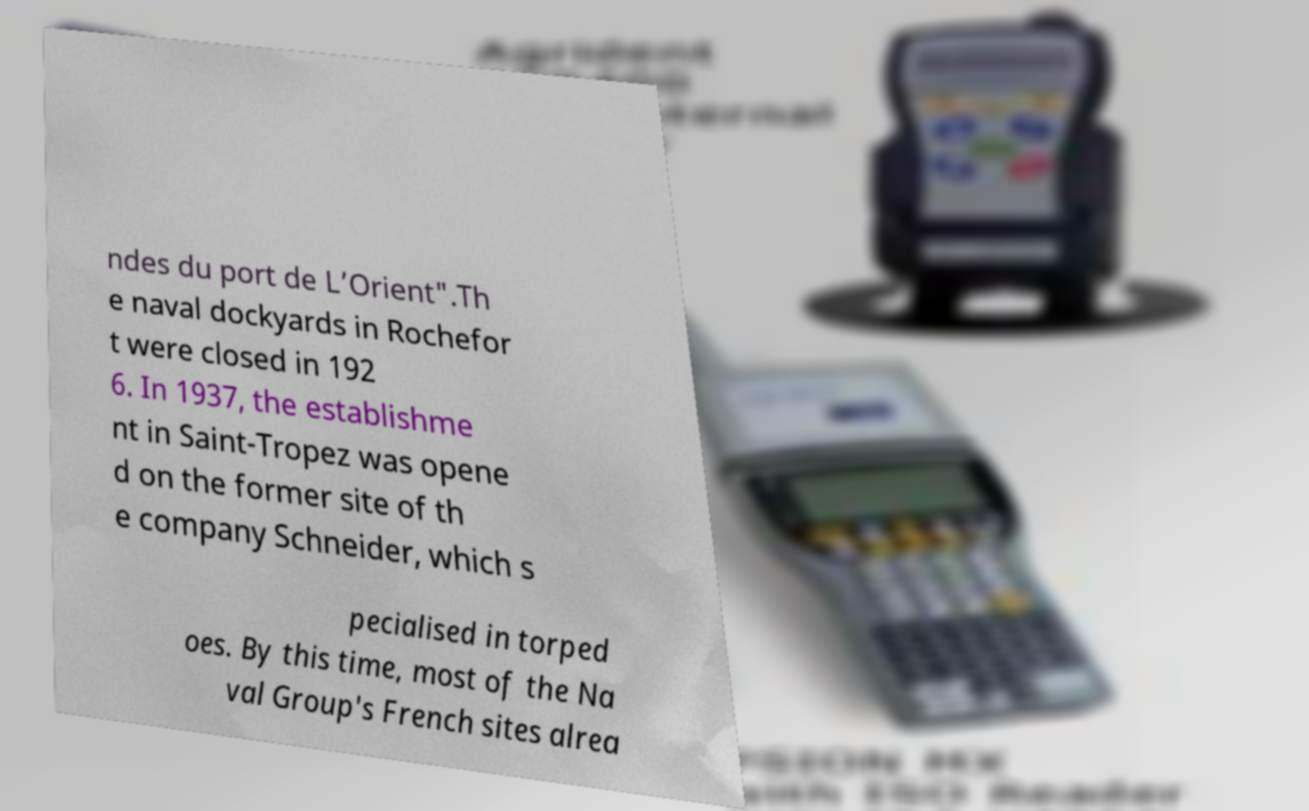Please read and relay the text visible in this image. What does it say? ndes du port de L’Orient".Th e naval dockyards in Rochefor t were closed in 192 6. In 1937, the establishme nt in Saint-Tropez was opene d on the former site of th e company Schneider, which s pecialised in torped oes. By this time, most of the Na val Group's French sites alrea 